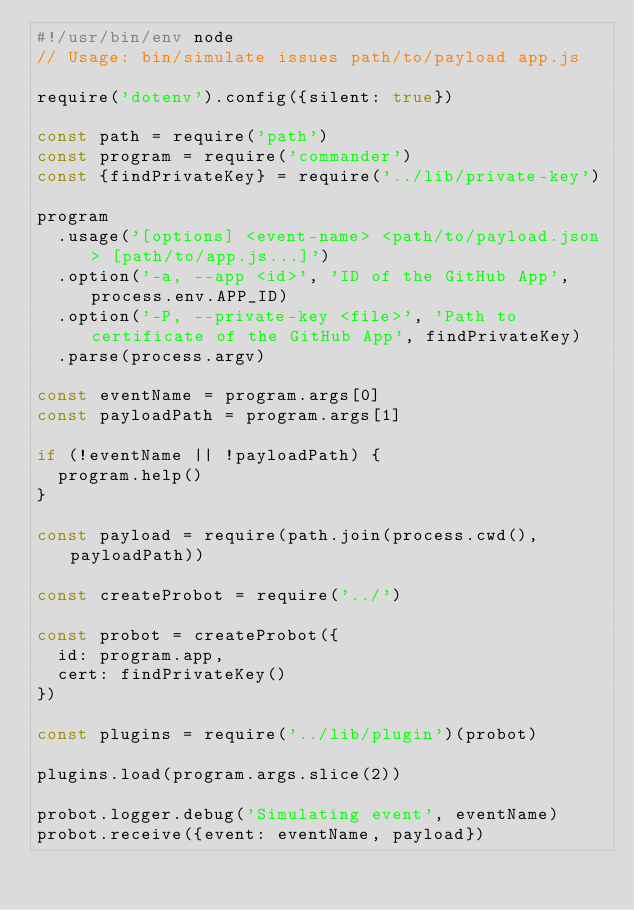<code> <loc_0><loc_0><loc_500><loc_500><_JavaScript_>#!/usr/bin/env node
// Usage: bin/simulate issues path/to/payload app.js

require('dotenv').config({silent: true})

const path = require('path')
const program = require('commander')
const {findPrivateKey} = require('../lib/private-key')

program
  .usage('[options] <event-name> <path/to/payload.json> [path/to/app.js...]')
  .option('-a, --app <id>', 'ID of the GitHub App', process.env.APP_ID)
  .option('-P, --private-key <file>', 'Path to certificate of the GitHub App', findPrivateKey)
  .parse(process.argv)

const eventName = program.args[0]
const payloadPath = program.args[1]

if (!eventName || !payloadPath) {
  program.help()
}

const payload = require(path.join(process.cwd(), payloadPath))

const createProbot = require('../')

const probot = createProbot({
  id: program.app,
  cert: findPrivateKey()
})

const plugins = require('../lib/plugin')(probot)

plugins.load(program.args.slice(2))

probot.logger.debug('Simulating event', eventName)
probot.receive({event: eventName, payload})
</code> 